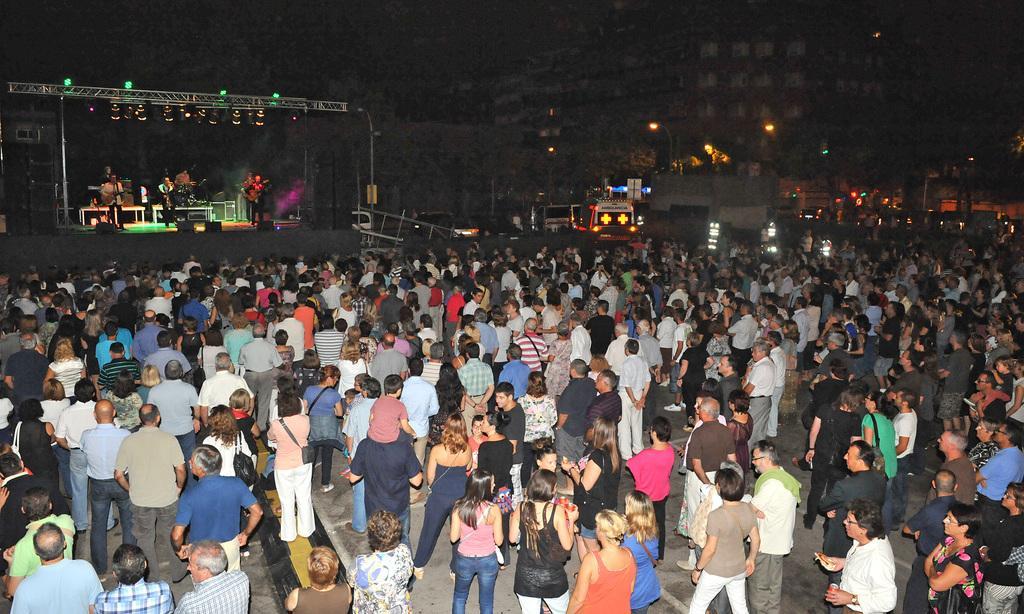Can you describe this image briefly? In this image, we can see some people standing and we can see the stage, there are some people performing on the stage, we can see the lights and there are some buildings. 